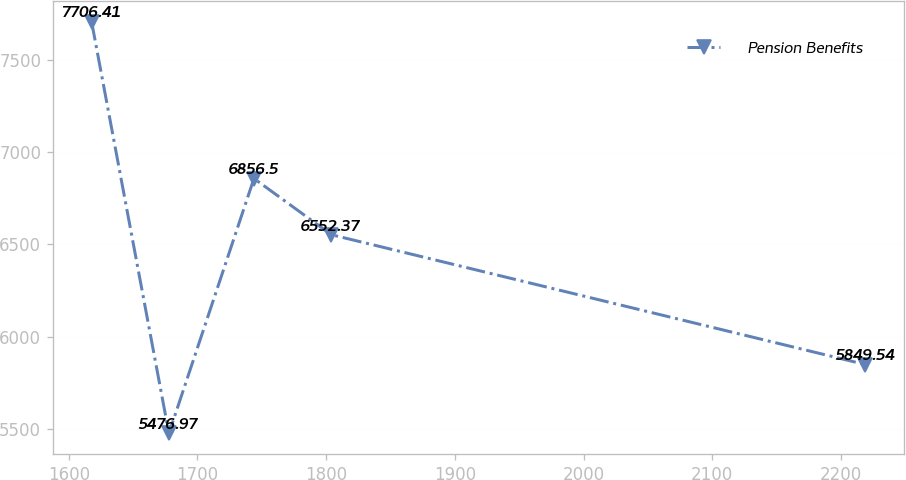<chart> <loc_0><loc_0><loc_500><loc_500><line_chart><ecel><fcel>Pension Benefits<nl><fcel>1617.7<fcel>7706.41<nl><fcel>1677.81<fcel>5476.97<nl><fcel>1743.88<fcel>6856.5<nl><fcel>1803.99<fcel>6552.37<nl><fcel>2218.83<fcel>5849.54<nl></chart> 